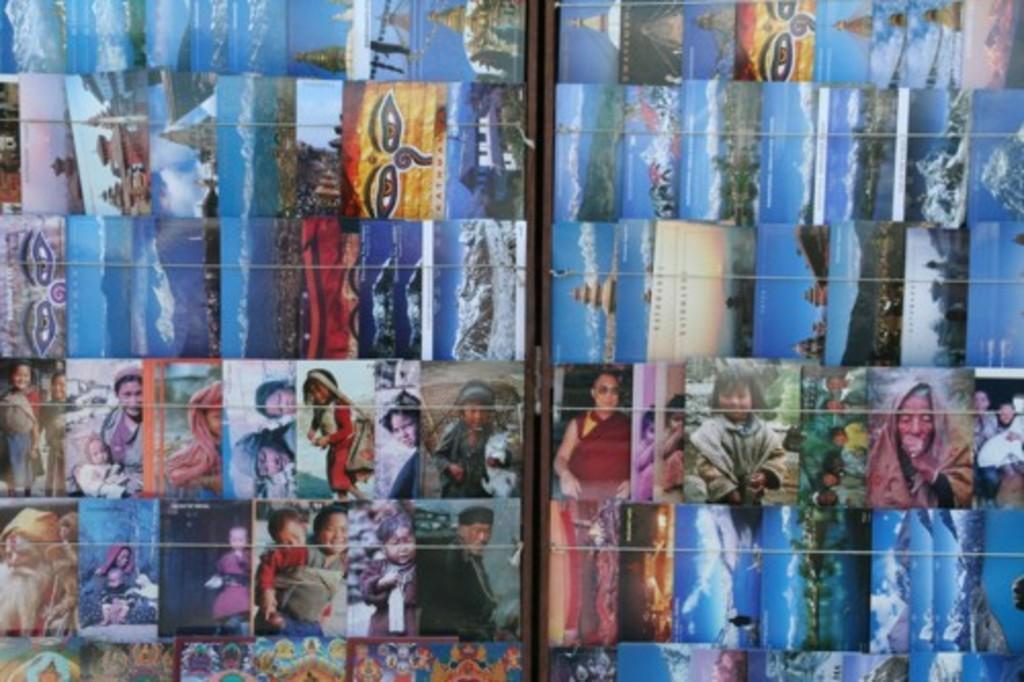In one or two sentences, can you explain what this image depicts? In the picture there is a board, on the board, there are many photographs present, there are people present in the photographs, there are beaches, there are trees, there are mountains present in the photographs. 